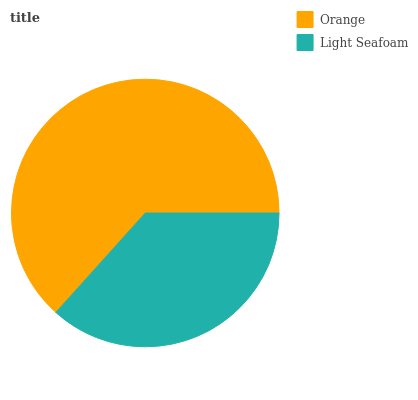Is Light Seafoam the minimum?
Answer yes or no. Yes. Is Orange the maximum?
Answer yes or no. Yes. Is Light Seafoam the maximum?
Answer yes or no. No. Is Orange greater than Light Seafoam?
Answer yes or no. Yes. Is Light Seafoam less than Orange?
Answer yes or no. Yes. Is Light Seafoam greater than Orange?
Answer yes or no. No. Is Orange less than Light Seafoam?
Answer yes or no. No. Is Orange the high median?
Answer yes or no. Yes. Is Light Seafoam the low median?
Answer yes or no. Yes. Is Light Seafoam the high median?
Answer yes or no. No. Is Orange the low median?
Answer yes or no. No. 